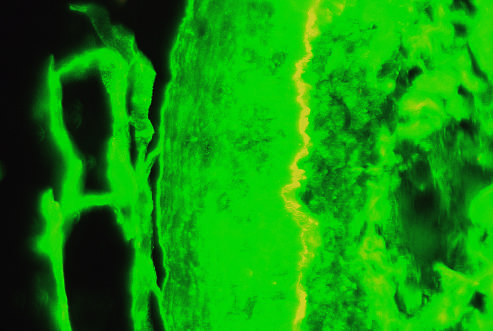where is the epidermis?
Answer the question using a single word or phrase. On the left side of the fluorescent band 